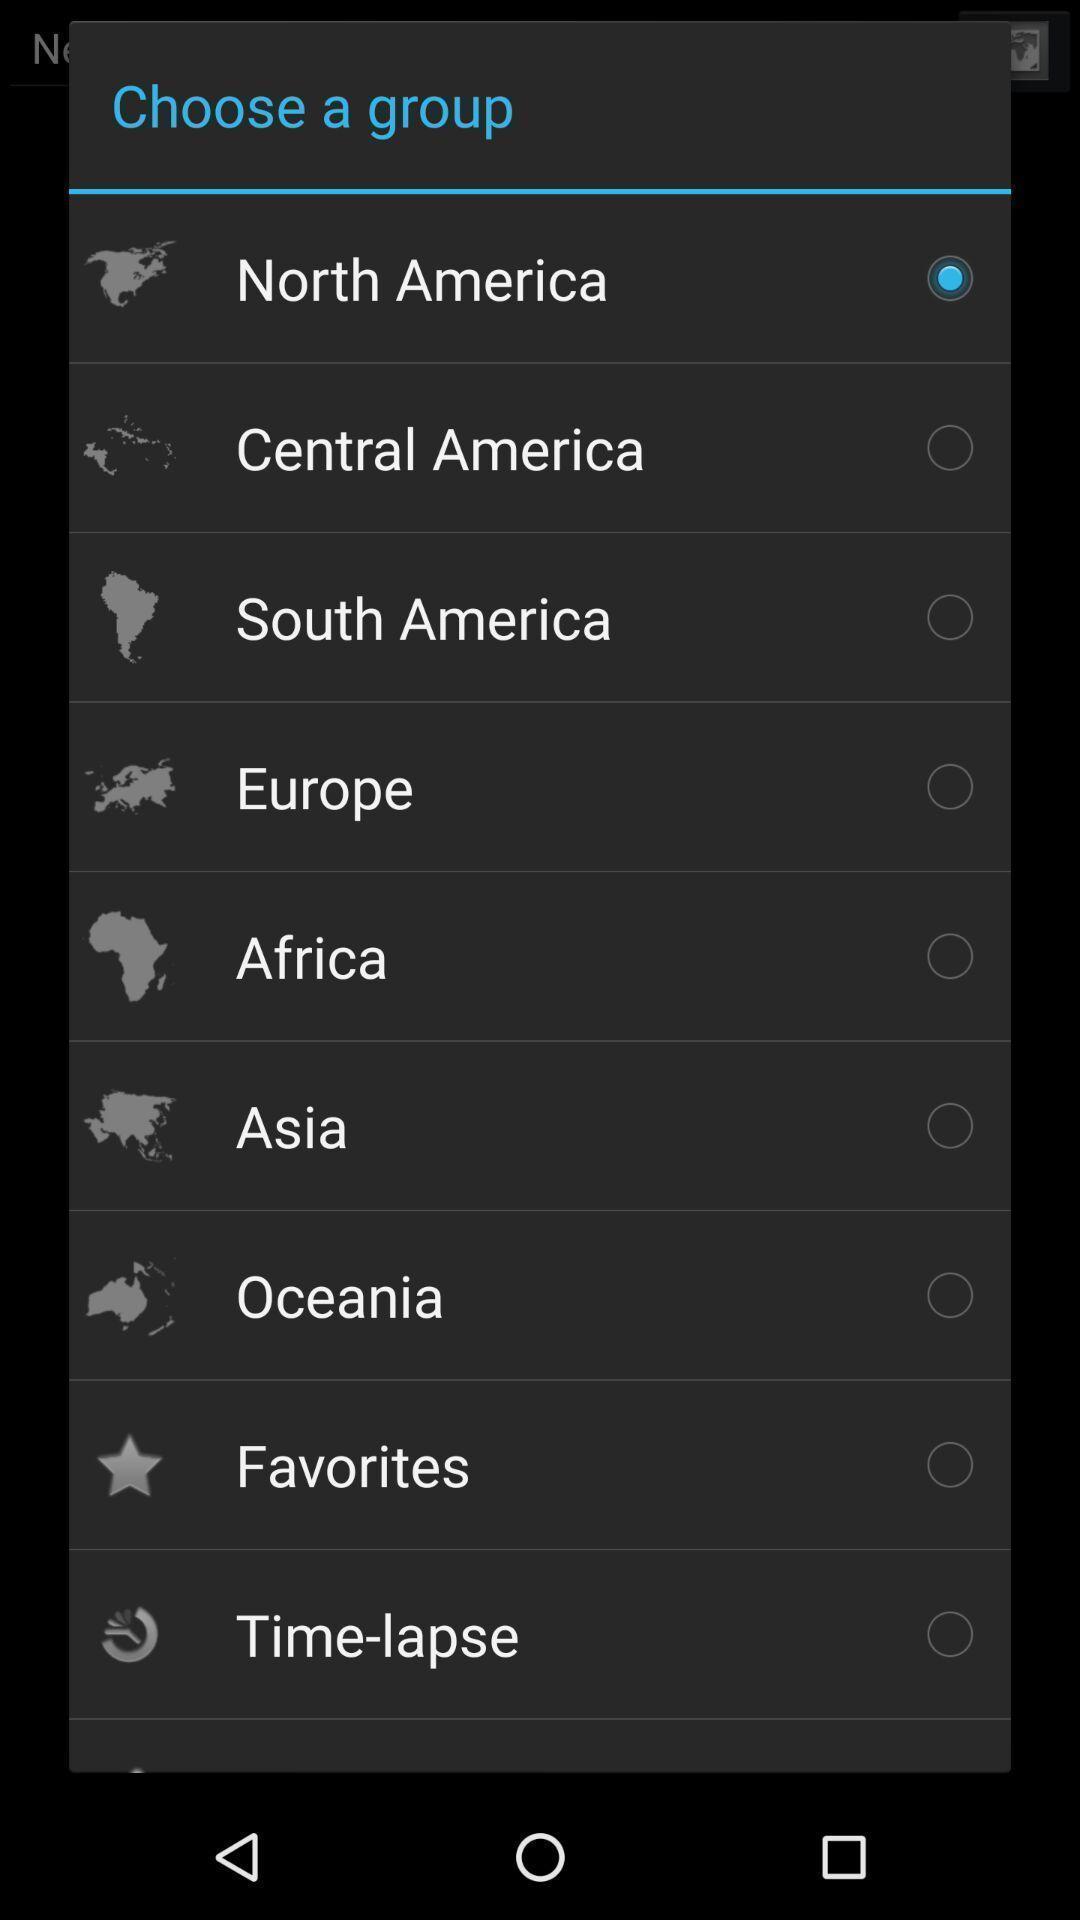Explain the elements present in this screenshot. Popup showing some options. 